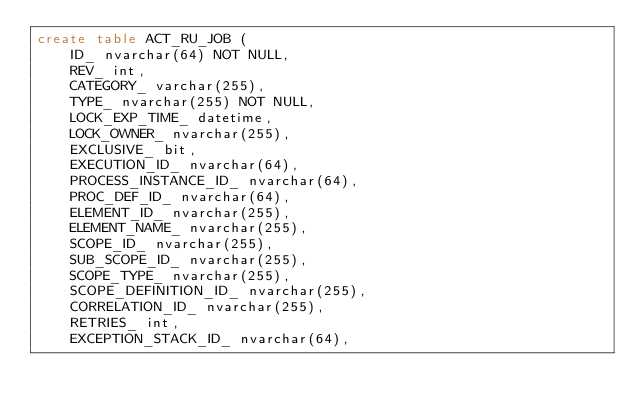<code> <loc_0><loc_0><loc_500><loc_500><_SQL_>create table ACT_RU_JOB (
    ID_ nvarchar(64) NOT NULL,
    REV_ int,
    CATEGORY_ varchar(255),
    TYPE_ nvarchar(255) NOT NULL,
    LOCK_EXP_TIME_ datetime,
    LOCK_OWNER_ nvarchar(255),
    EXCLUSIVE_ bit,
    EXECUTION_ID_ nvarchar(64),
    PROCESS_INSTANCE_ID_ nvarchar(64),
    PROC_DEF_ID_ nvarchar(64),
    ELEMENT_ID_ nvarchar(255),
    ELEMENT_NAME_ nvarchar(255),
    SCOPE_ID_ nvarchar(255),
    SUB_SCOPE_ID_ nvarchar(255),
    SCOPE_TYPE_ nvarchar(255),
    SCOPE_DEFINITION_ID_ nvarchar(255),
    CORRELATION_ID_ nvarchar(255),
    RETRIES_ int,
    EXCEPTION_STACK_ID_ nvarchar(64),</code> 